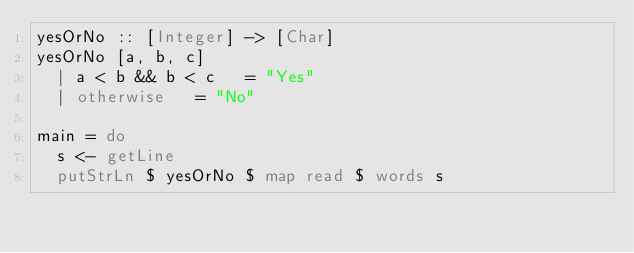Convert code to text. <code><loc_0><loc_0><loc_500><loc_500><_Haskell_>yesOrNo :: [Integer] -> [Char]
yesOrNo [a, b, c]
  | a < b && b < c   = "Yes"
  | otherwise   = "No"

main = do
  s <- getLine
  putStrLn $ yesOrNo $ map read $ words s</code> 